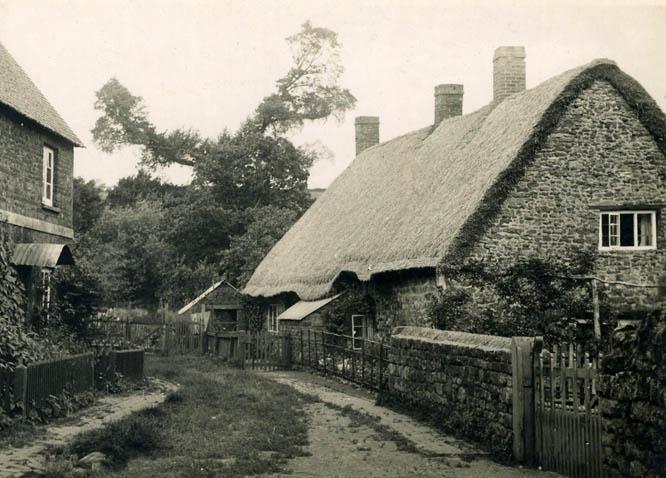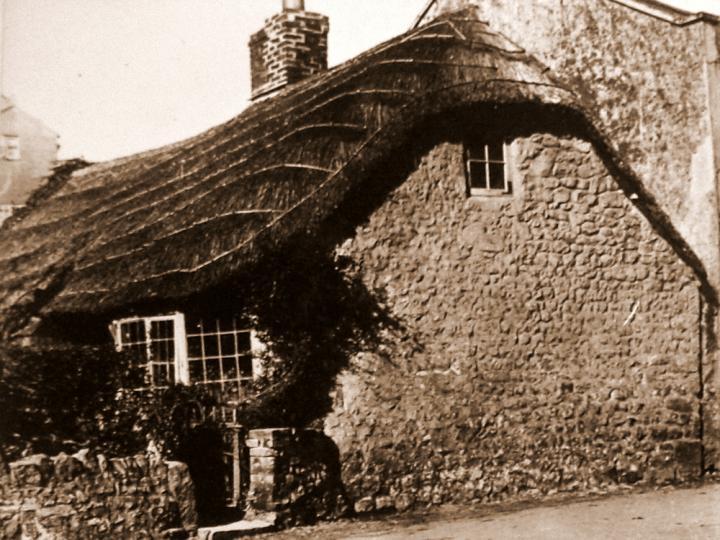The first image is the image on the left, the second image is the image on the right. Assess this claim about the two images: "The building in the left image has exactly one chimney.". Correct or not? Answer yes or no. No. 